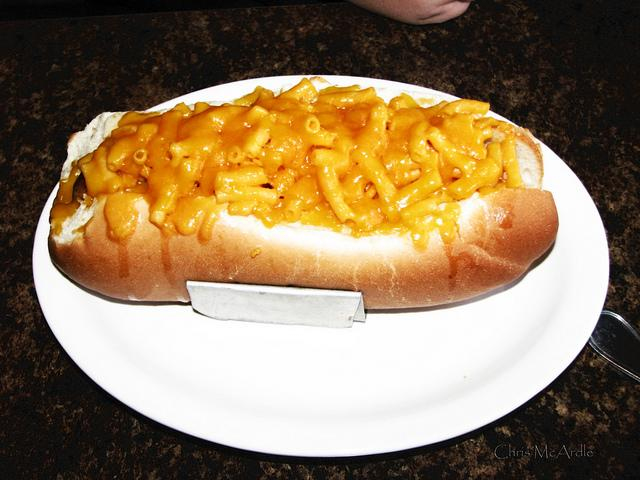What type of food is on top of the bread? macaroni 